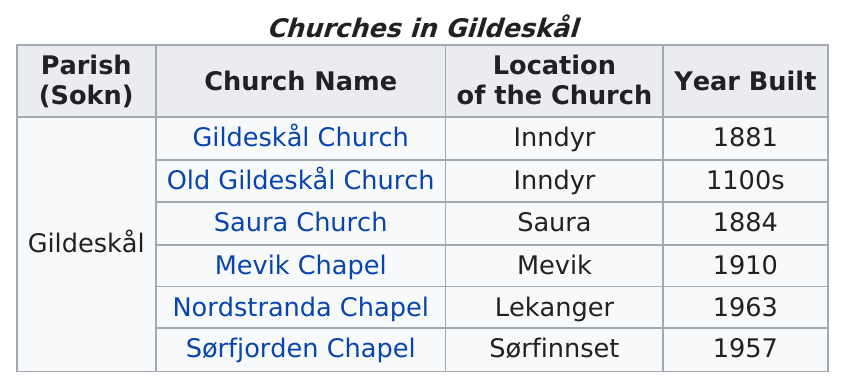Draw attention to some important aspects in this diagram. Saura Church, in addition to Gildeskål Church, was also built in the 1800s. 